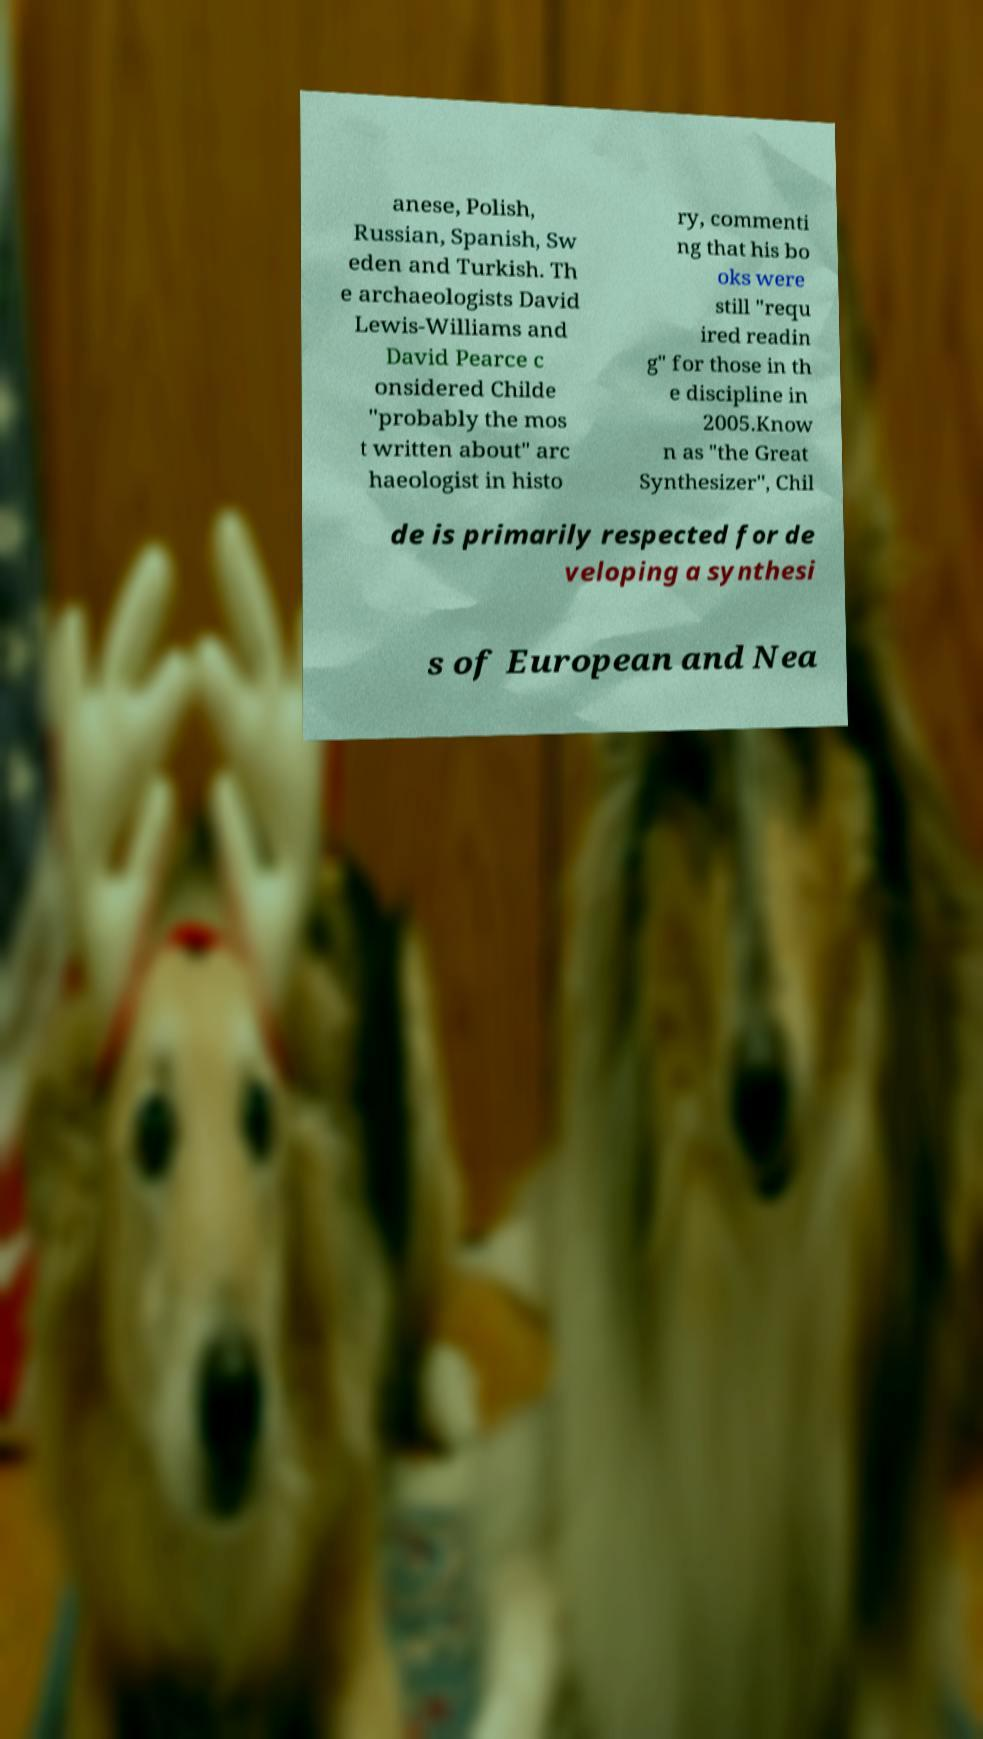Please read and relay the text visible in this image. What does it say? anese, Polish, Russian, Spanish, Sw eden and Turkish. Th e archaeologists David Lewis-Williams and David Pearce c onsidered Childe "probably the mos t written about" arc haeologist in histo ry, commenti ng that his bo oks were still "requ ired readin g" for those in th e discipline in 2005.Know n as "the Great Synthesizer", Chil de is primarily respected for de veloping a synthesi s of European and Nea 